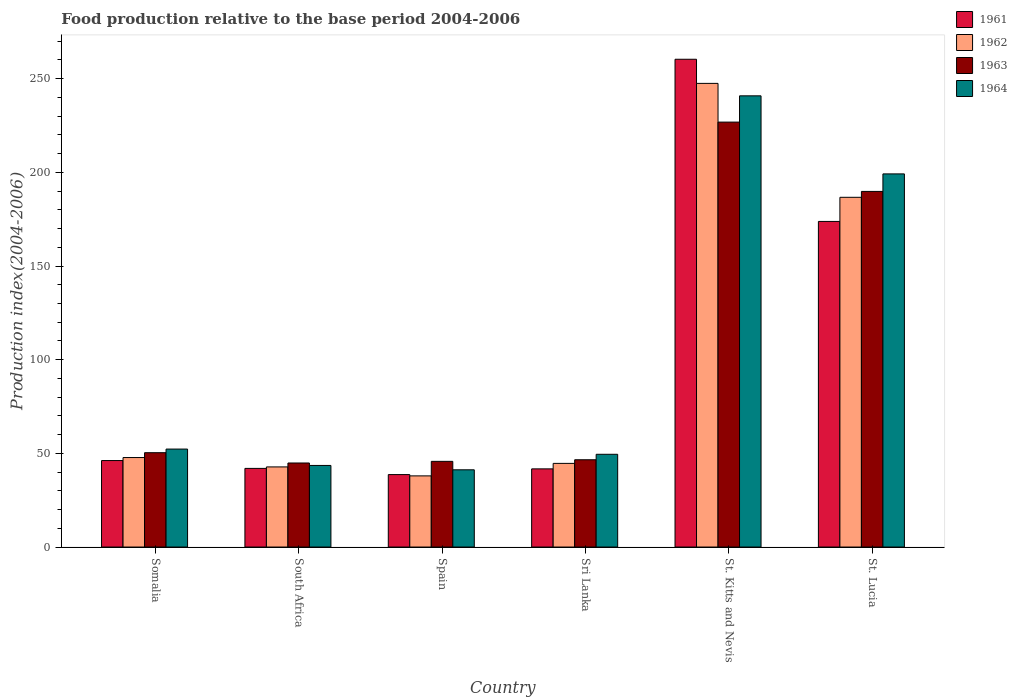How many different coloured bars are there?
Provide a succinct answer. 4. How many groups of bars are there?
Ensure brevity in your answer.  6. Are the number of bars on each tick of the X-axis equal?
Offer a terse response. Yes. How many bars are there on the 5th tick from the left?
Give a very brief answer. 4. How many bars are there on the 1st tick from the right?
Offer a terse response. 4. What is the label of the 6th group of bars from the left?
Provide a short and direct response. St. Lucia. In how many cases, is the number of bars for a given country not equal to the number of legend labels?
Your answer should be compact. 0. What is the food production index in 1964 in Somalia?
Your response must be concise. 52.3. Across all countries, what is the maximum food production index in 1962?
Make the answer very short. 247.5. Across all countries, what is the minimum food production index in 1963?
Your response must be concise. 44.87. In which country was the food production index in 1963 maximum?
Give a very brief answer. St. Kitts and Nevis. What is the total food production index in 1964 in the graph?
Make the answer very short. 626.63. What is the difference between the food production index in 1962 in Spain and that in Sri Lanka?
Offer a very short reply. -6.67. What is the difference between the food production index in 1964 in South Africa and the food production index in 1963 in St. Kitts and Nevis?
Provide a short and direct response. -183.27. What is the average food production index in 1963 per country?
Make the answer very short. 100.7. What is the difference between the food production index of/in 1961 and food production index of/in 1964 in Somalia?
Your answer should be very brief. -6.13. In how many countries, is the food production index in 1962 greater than 260?
Provide a succinct answer. 0. What is the ratio of the food production index in 1961 in St. Kitts and Nevis to that in St. Lucia?
Your answer should be very brief. 1.5. Is the food production index in 1961 in Sri Lanka less than that in St. Lucia?
Offer a very short reply. Yes. What is the difference between the highest and the second highest food production index in 1963?
Your answer should be very brief. 176.47. What is the difference between the highest and the lowest food production index in 1961?
Your response must be concise. 221.69. In how many countries, is the food production index in 1964 greater than the average food production index in 1964 taken over all countries?
Offer a very short reply. 2. Is it the case that in every country, the sum of the food production index in 1964 and food production index in 1962 is greater than the sum of food production index in 1961 and food production index in 1963?
Offer a terse response. No. What does the 1st bar from the left in South Africa represents?
Provide a short and direct response. 1961. What does the 1st bar from the right in Somalia represents?
Provide a succinct answer. 1964. Is it the case that in every country, the sum of the food production index in 1963 and food production index in 1961 is greater than the food production index in 1964?
Keep it short and to the point. Yes. How many countries are there in the graph?
Ensure brevity in your answer.  6. Does the graph contain any zero values?
Keep it short and to the point. No. Does the graph contain grids?
Provide a succinct answer. No. How are the legend labels stacked?
Offer a very short reply. Vertical. What is the title of the graph?
Give a very brief answer. Food production relative to the base period 2004-2006. Does "1999" appear as one of the legend labels in the graph?
Offer a very short reply. No. What is the label or title of the Y-axis?
Your answer should be compact. Production index(2004-2006). What is the Production index(2004-2006) of 1961 in Somalia?
Your answer should be very brief. 46.17. What is the Production index(2004-2006) of 1962 in Somalia?
Your answer should be very brief. 47.78. What is the Production index(2004-2006) in 1963 in Somalia?
Give a very brief answer. 50.36. What is the Production index(2004-2006) of 1964 in Somalia?
Ensure brevity in your answer.  52.3. What is the Production index(2004-2006) in 1961 in South Africa?
Your answer should be compact. 41.98. What is the Production index(2004-2006) in 1962 in South Africa?
Your answer should be compact. 42.77. What is the Production index(2004-2006) in 1963 in South Africa?
Offer a very short reply. 44.87. What is the Production index(2004-2006) in 1964 in South Africa?
Make the answer very short. 43.56. What is the Production index(2004-2006) in 1961 in Spain?
Offer a very short reply. 38.68. What is the Production index(2004-2006) in 1962 in Spain?
Your response must be concise. 37.99. What is the Production index(2004-2006) in 1963 in Spain?
Ensure brevity in your answer.  45.74. What is the Production index(2004-2006) in 1964 in Spain?
Offer a very short reply. 41.23. What is the Production index(2004-2006) in 1961 in Sri Lanka?
Make the answer very short. 41.73. What is the Production index(2004-2006) of 1962 in Sri Lanka?
Your answer should be compact. 44.66. What is the Production index(2004-2006) of 1963 in Sri Lanka?
Your answer should be very brief. 46.59. What is the Production index(2004-2006) of 1964 in Sri Lanka?
Keep it short and to the point. 49.51. What is the Production index(2004-2006) of 1961 in St. Kitts and Nevis?
Provide a short and direct response. 260.37. What is the Production index(2004-2006) in 1962 in St. Kitts and Nevis?
Your response must be concise. 247.5. What is the Production index(2004-2006) of 1963 in St. Kitts and Nevis?
Make the answer very short. 226.83. What is the Production index(2004-2006) in 1964 in St. Kitts and Nevis?
Your response must be concise. 240.85. What is the Production index(2004-2006) of 1961 in St. Lucia?
Offer a terse response. 173.81. What is the Production index(2004-2006) in 1962 in St. Lucia?
Offer a very short reply. 186.69. What is the Production index(2004-2006) of 1963 in St. Lucia?
Keep it short and to the point. 189.83. What is the Production index(2004-2006) of 1964 in St. Lucia?
Provide a short and direct response. 199.18. Across all countries, what is the maximum Production index(2004-2006) of 1961?
Provide a short and direct response. 260.37. Across all countries, what is the maximum Production index(2004-2006) in 1962?
Your response must be concise. 247.5. Across all countries, what is the maximum Production index(2004-2006) of 1963?
Your answer should be compact. 226.83. Across all countries, what is the maximum Production index(2004-2006) of 1964?
Keep it short and to the point. 240.85. Across all countries, what is the minimum Production index(2004-2006) in 1961?
Offer a very short reply. 38.68. Across all countries, what is the minimum Production index(2004-2006) in 1962?
Keep it short and to the point. 37.99. Across all countries, what is the minimum Production index(2004-2006) in 1963?
Offer a very short reply. 44.87. Across all countries, what is the minimum Production index(2004-2006) of 1964?
Ensure brevity in your answer.  41.23. What is the total Production index(2004-2006) in 1961 in the graph?
Your answer should be very brief. 602.74. What is the total Production index(2004-2006) in 1962 in the graph?
Give a very brief answer. 607.39. What is the total Production index(2004-2006) of 1963 in the graph?
Your answer should be compact. 604.22. What is the total Production index(2004-2006) of 1964 in the graph?
Ensure brevity in your answer.  626.63. What is the difference between the Production index(2004-2006) in 1961 in Somalia and that in South Africa?
Your answer should be very brief. 4.19. What is the difference between the Production index(2004-2006) in 1962 in Somalia and that in South Africa?
Offer a very short reply. 5.01. What is the difference between the Production index(2004-2006) in 1963 in Somalia and that in South Africa?
Your response must be concise. 5.49. What is the difference between the Production index(2004-2006) of 1964 in Somalia and that in South Africa?
Provide a short and direct response. 8.74. What is the difference between the Production index(2004-2006) in 1961 in Somalia and that in Spain?
Your answer should be very brief. 7.49. What is the difference between the Production index(2004-2006) in 1962 in Somalia and that in Spain?
Ensure brevity in your answer.  9.79. What is the difference between the Production index(2004-2006) in 1963 in Somalia and that in Spain?
Ensure brevity in your answer.  4.62. What is the difference between the Production index(2004-2006) of 1964 in Somalia and that in Spain?
Make the answer very short. 11.07. What is the difference between the Production index(2004-2006) in 1961 in Somalia and that in Sri Lanka?
Offer a terse response. 4.44. What is the difference between the Production index(2004-2006) of 1962 in Somalia and that in Sri Lanka?
Provide a short and direct response. 3.12. What is the difference between the Production index(2004-2006) of 1963 in Somalia and that in Sri Lanka?
Your answer should be compact. 3.77. What is the difference between the Production index(2004-2006) of 1964 in Somalia and that in Sri Lanka?
Provide a short and direct response. 2.79. What is the difference between the Production index(2004-2006) in 1961 in Somalia and that in St. Kitts and Nevis?
Your answer should be compact. -214.2. What is the difference between the Production index(2004-2006) of 1962 in Somalia and that in St. Kitts and Nevis?
Provide a short and direct response. -199.72. What is the difference between the Production index(2004-2006) of 1963 in Somalia and that in St. Kitts and Nevis?
Offer a terse response. -176.47. What is the difference between the Production index(2004-2006) of 1964 in Somalia and that in St. Kitts and Nevis?
Offer a terse response. -188.55. What is the difference between the Production index(2004-2006) in 1961 in Somalia and that in St. Lucia?
Keep it short and to the point. -127.64. What is the difference between the Production index(2004-2006) of 1962 in Somalia and that in St. Lucia?
Make the answer very short. -138.91. What is the difference between the Production index(2004-2006) in 1963 in Somalia and that in St. Lucia?
Offer a very short reply. -139.47. What is the difference between the Production index(2004-2006) of 1964 in Somalia and that in St. Lucia?
Give a very brief answer. -146.88. What is the difference between the Production index(2004-2006) of 1961 in South Africa and that in Spain?
Ensure brevity in your answer.  3.3. What is the difference between the Production index(2004-2006) of 1962 in South Africa and that in Spain?
Provide a short and direct response. 4.78. What is the difference between the Production index(2004-2006) of 1963 in South Africa and that in Spain?
Your answer should be compact. -0.87. What is the difference between the Production index(2004-2006) in 1964 in South Africa and that in Spain?
Keep it short and to the point. 2.33. What is the difference between the Production index(2004-2006) in 1962 in South Africa and that in Sri Lanka?
Your answer should be very brief. -1.89. What is the difference between the Production index(2004-2006) in 1963 in South Africa and that in Sri Lanka?
Provide a succinct answer. -1.72. What is the difference between the Production index(2004-2006) in 1964 in South Africa and that in Sri Lanka?
Provide a short and direct response. -5.95. What is the difference between the Production index(2004-2006) in 1961 in South Africa and that in St. Kitts and Nevis?
Provide a short and direct response. -218.39. What is the difference between the Production index(2004-2006) of 1962 in South Africa and that in St. Kitts and Nevis?
Offer a terse response. -204.73. What is the difference between the Production index(2004-2006) in 1963 in South Africa and that in St. Kitts and Nevis?
Your answer should be very brief. -181.96. What is the difference between the Production index(2004-2006) of 1964 in South Africa and that in St. Kitts and Nevis?
Your answer should be compact. -197.29. What is the difference between the Production index(2004-2006) in 1961 in South Africa and that in St. Lucia?
Give a very brief answer. -131.83. What is the difference between the Production index(2004-2006) of 1962 in South Africa and that in St. Lucia?
Offer a terse response. -143.92. What is the difference between the Production index(2004-2006) of 1963 in South Africa and that in St. Lucia?
Your answer should be very brief. -144.96. What is the difference between the Production index(2004-2006) in 1964 in South Africa and that in St. Lucia?
Provide a succinct answer. -155.62. What is the difference between the Production index(2004-2006) in 1961 in Spain and that in Sri Lanka?
Offer a terse response. -3.05. What is the difference between the Production index(2004-2006) of 1962 in Spain and that in Sri Lanka?
Provide a succinct answer. -6.67. What is the difference between the Production index(2004-2006) of 1963 in Spain and that in Sri Lanka?
Provide a succinct answer. -0.85. What is the difference between the Production index(2004-2006) of 1964 in Spain and that in Sri Lanka?
Keep it short and to the point. -8.28. What is the difference between the Production index(2004-2006) of 1961 in Spain and that in St. Kitts and Nevis?
Provide a succinct answer. -221.69. What is the difference between the Production index(2004-2006) of 1962 in Spain and that in St. Kitts and Nevis?
Make the answer very short. -209.51. What is the difference between the Production index(2004-2006) of 1963 in Spain and that in St. Kitts and Nevis?
Your response must be concise. -181.09. What is the difference between the Production index(2004-2006) in 1964 in Spain and that in St. Kitts and Nevis?
Your answer should be very brief. -199.62. What is the difference between the Production index(2004-2006) of 1961 in Spain and that in St. Lucia?
Give a very brief answer. -135.13. What is the difference between the Production index(2004-2006) in 1962 in Spain and that in St. Lucia?
Keep it short and to the point. -148.7. What is the difference between the Production index(2004-2006) of 1963 in Spain and that in St. Lucia?
Provide a short and direct response. -144.09. What is the difference between the Production index(2004-2006) of 1964 in Spain and that in St. Lucia?
Keep it short and to the point. -157.95. What is the difference between the Production index(2004-2006) in 1961 in Sri Lanka and that in St. Kitts and Nevis?
Make the answer very short. -218.64. What is the difference between the Production index(2004-2006) in 1962 in Sri Lanka and that in St. Kitts and Nevis?
Give a very brief answer. -202.84. What is the difference between the Production index(2004-2006) of 1963 in Sri Lanka and that in St. Kitts and Nevis?
Keep it short and to the point. -180.24. What is the difference between the Production index(2004-2006) in 1964 in Sri Lanka and that in St. Kitts and Nevis?
Your response must be concise. -191.34. What is the difference between the Production index(2004-2006) of 1961 in Sri Lanka and that in St. Lucia?
Give a very brief answer. -132.08. What is the difference between the Production index(2004-2006) in 1962 in Sri Lanka and that in St. Lucia?
Provide a succinct answer. -142.03. What is the difference between the Production index(2004-2006) in 1963 in Sri Lanka and that in St. Lucia?
Your answer should be compact. -143.24. What is the difference between the Production index(2004-2006) in 1964 in Sri Lanka and that in St. Lucia?
Provide a short and direct response. -149.67. What is the difference between the Production index(2004-2006) in 1961 in St. Kitts and Nevis and that in St. Lucia?
Your answer should be very brief. 86.56. What is the difference between the Production index(2004-2006) in 1962 in St. Kitts and Nevis and that in St. Lucia?
Keep it short and to the point. 60.81. What is the difference between the Production index(2004-2006) in 1964 in St. Kitts and Nevis and that in St. Lucia?
Give a very brief answer. 41.67. What is the difference between the Production index(2004-2006) of 1961 in Somalia and the Production index(2004-2006) of 1963 in South Africa?
Offer a very short reply. 1.3. What is the difference between the Production index(2004-2006) in 1961 in Somalia and the Production index(2004-2006) in 1964 in South Africa?
Give a very brief answer. 2.61. What is the difference between the Production index(2004-2006) in 1962 in Somalia and the Production index(2004-2006) in 1963 in South Africa?
Make the answer very short. 2.91. What is the difference between the Production index(2004-2006) of 1962 in Somalia and the Production index(2004-2006) of 1964 in South Africa?
Offer a very short reply. 4.22. What is the difference between the Production index(2004-2006) of 1961 in Somalia and the Production index(2004-2006) of 1962 in Spain?
Provide a succinct answer. 8.18. What is the difference between the Production index(2004-2006) of 1961 in Somalia and the Production index(2004-2006) of 1963 in Spain?
Provide a short and direct response. 0.43. What is the difference between the Production index(2004-2006) in 1961 in Somalia and the Production index(2004-2006) in 1964 in Spain?
Provide a short and direct response. 4.94. What is the difference between the Production index(2004-2006) of 1962 in Somalia and the Production index(2004-2006) of 1963 in Spain?
Your response must be concise. 2.04. What is the difference between the Production index(2004-2006) in 1962 in Somalia and the Production index(2004-2006) in 1964 in Spain?
Your response must be concise. 6.55. What is the difference between the Production index(2004-2006) of 1963 in Somalia and the Production index(2004-2006) of 1964 in Spain?
Make the answer very short. 9.13. What is the difference between the Production index(2004-2006) of 1961 in Somalia and the Production index(2004-2006) of 1962 in Sri Lanka?
Give a very brief answer. 1.51. What is the difference between the Production index(2004-2006) in 1961 in Somalia and the Production index(2004-2006) in 1963 in Sri Lanka?
Give a very brief answer. -0.42. What is the difference between the Production index(2004-2006) in 1961 in Somalia and the Production index(2004-2006) in 1964 in Sri Lanka?
Provide a succinct answer. -3.34. What is the difference between the Production index(2004-2006) of 1962 in Somalia and the Production index(2004-2006) of 1963 in Sri Lanka?
Your answer should be compact. 1.19. What is the difference between the Production index(2004-2006) in 1962 in Somalia and the Production index(2004-2006) in 1964 in Sri Lanka?
Keep it short and to the point. -1.73. What is the difference between the Production index(2004-2006) in 1961 in Somalia and the Production index(2004-2006) in 1962 in St. Kitts and Nevis?
Your response must be concise. -201.33. What is the difference between the Production index(2004-2006) of 1961 in Somalia and the Production index(2004-2006) of 1963 in St. Kitts and Nevis?
Your answer should be very brief. -180.66. What is the difference between the Production index(2004-2006) in 1961 in Somalia and the Production index(2004-2006) in 1964 in St. Kitts and Nevis?
Offer a very short reply. -194.68. What is the difference between the Production index(2004-2006) in 1962 in Somalia and the Production index(2004-2006) in 1963 in St. Kitts and Nevis?
Give a very brief answer. -179.05. What is the difference between the Production index(2004-2006) in 1962 in Somalia and the Production index(2004-2006) in 1964 in St. Kitts and Nevis?
Keep it short and to the point. -193.07. What is the difference between the Production index(2004-2006) in 1963 in Somalia and the Production index(2004-2006) in 1964 in St. Kitts and Nevis?
Give a very brief answer. -190.49. What is the difference between the Production index(2004-2006) in 1961 in Somalia and the Production index(2004-2006) in 1962 in St. Lucia?
Offer a terse response. -140.52. What is the difference between the Production index(2004-2006) in 1961 in Somalia and the Production index(2004-2006) in 1963 in St. Lucia?
Offer a terse response. -143.66. What is the difference between the Production index(2004-2006) in 1961 in Somalia and the Production index(2004-2006) in 1964 in St. Lucia?
Make the answer very short. -153.01. What is the difference between the Production index(2004-2006) in 1962 in Somalia and the Production index(2004-2006) in 1963 in St. Lucia?
Offer a very short reply. -142.05. What is the difference between the Production index(2004-2006) of 1962 in Somalia and the Production index(2004-2006) of 1964 in St. Lucia?
Your answer should be compact. -151.4. What is the difference between the Production index(2004-2006) of 1963 in Somalia and the Production index(2004-2006) of 1964 in St. Lucia?
Keep it short and to the point. -148.82. What is the difference between the Production index(2004-2006) in 1961 in South Africa and the Production index(2004-2006) in 1962 in Spain?
Give a very brief answer. 3.99. What is the difference between the Production index(2004-2006) in 1961 in South Africa and the Production index(2004-2006) in 1963 in Spain?
Provide a short and direct response. -3.76. What is the difference between the Production index(2004-2006) of 1962 in South Africa and the Production index(2004-2006) of 1963 in Spain?
Ensure brevity in your answer.  -2.97. What is the difference between the Production index(2004-2006) in 1962 in South Africa and the Production index(2004-2006) in 1964 in Spain?
Provide a short and direct response. 1.54. What is the difference between the Production index(2004-2006) in 1963 in South Africa and the Production index(2004-2006) in 1964 in Spain?
Make the answer very short. 3.64. What is the difference between the Production index(2004-2006) in 1961 in South Africa and the Production index(2004-2006) in 1962 in Sri Lanka?
Your answer should be very brief. -2.68. What is the difference between the Production index(2004-2006) of 1961 in South Africa and the Production index(2004-2006) of 1963 in Sri Lanka?
Your answer should be compact. -4.61. What is the difference between the Production index(2004-2006) of 1961 in South Africa and the Production index(2004-2006) of 1964 in Sri Lanka?
Offer a terse response. -7.53. What is the difference between the Production index(2004-2006) of 1962 in South Africa and the Production index(2004-2006) of 1963 in Sri Lanka?
Make the answer very short. -3.82. What is the difference between the Production index(2004-2006) of 1962 in South Africa and the Production index(2004-2006) of 1964 in Sri Lanka?
Keep it short and to the point. -6.74. What is the difference between the Production index(2004-2006) in 1963 in South Africa and the Production index(2004-2006) in 1964 in Sri Lanka?
Give a very brief answer. -4.64. What is the difference between the Production index(2004-2006) in 1961 in South Africa and the Production index(2004-2006) in 1962 in St. Kitts and Nevis?
Give a very brief answer. -205.52. What is the difference between the Production index(2004-2006) in 1961 in South Africa and the Production index(2004-2006) in 1963 in St. Kitts and Nevis?
Keep it short and to the point. -184.85. What is the difference between the Production index(2004-2006) in 1961 in South Africa and the Production index(2004-2006) in 1964 in St. Kitts and Nevis?
Your answer should be compact. -198.87. What is the difference between the Production index(2004-2006) in 1962 in South Africa and the Production index(2004-2006) in 1963 in St. Kitts and Nevis?
Offer a terse response. -184.06. What is the difference between the Production index(2004-2006) in 1962 in South Africa and the Production index(2004-2006) in 1964 in St. Kitts and Nevis?
Ensure brevity in your answer.  -198.08. What is the difference between the Production index(2004-2006) of 1963 in South Africa and the Production index(2004-2006) of 1964 in St. Kitts and Nevis?
Offer a very short reply. -195.98. What is the difference between the Production index(2004-2006) of 1961 in South Africa and the Production index(2004-2006) of 1962 in St. Lucia?
Give a very brief answer. -144.71. What is the difference between the Production index(2004-2006) in 1961 in South Africa and the Production index(2004-2006) in 1963 in St. Lucia?
Give a very brief answer. -147.85. What is the difference between the Production index(2004-2006) of 1961 in South Africa and the Production index(2004-2006) of 1964 in St. Lucia?
Ensure brevity in your answer.  -157.2. What is the difference between the Production index(2004-2006) in 1962 in South Africa and the Production index(2004-2006) in 1963 in St. Lucia?
Keep it short and to the point. -147.06. What is the difference between the Production index(2004-2006) of 1962 in South Africa and the Production index(2004-2006) of 1964 in St. Lucia?
Offer a terse response. -156.41. What is the difference between the Production index(2004-2006) in 1963 in South Africa and the Production index(2004-2006) in 1964 in St. Lucia?
Provide a short and direct response. -154.31. What is the difference between the Production index(2004-2006) in 1961 in Spain and the Production index(2004-2006) in 1962 in Sri Lanka?
Provide a short and direct response. -5.98. What is the difference between the Production index(2004-2006) in 1961 in Spain and the Production index(2004-2006) in 1963 in Sri Lanka?
Ensure brevity in your answer.  -7.91. What is the difference between the Production index(2004-2006) of 1961 in Spain and the Production index(2004-2006) of 1964 in Sri Lanka?
Provide a succinct answer. -10.83. What is the difference between the Production index(2004-2006) of 1962 in Spain and the Production index(2004-2006) of 1964 in Sri Lanka?
Make the answer very short. -11.52. What is the difference between the Production index(2004-2006) in 1963 in Spain and the Production index(2004-2006) in 1964 in Sri Lanka?
Make the answer very short. -3.77. What is the difference between the Production index(2004-2006) in 1961 in Spain and the Production index(2004-2006) in 1962 in St. Kitts and Nevis?
Your answer should be very brief. -208.82. What is the difference between the Production index(2004-2006) of 1961 in Spain and the Production index(2004-2006) of 1963 in St. Kitts and Nevis?
Your answer should be very brief. -188.15. What is the difference between the Production index(2004-2006) in 1961 in Spain and the Production index(2004-2006) in 1964 in St. Kitts and Nevis?
Your answer should be compact. -202.17. What is the difference between the Production index(2004-2006) in 1962 in Spain and the Production index(2004-2006) in 1963 in St. Kitts and Nevis?
Ensure brevity in your answer.  -188.84. What is the difference between the Production index(2004-2006) of 1962 in Spain and the Production index(2004-2006) of 1964 in St. Kitts and Nevis?
Give a very brief answer. -202.86. What is the difference between the Production index(2004-2006) of 1963 in Spain and the Production index(2004-2006) of 1964 in St. Kitts and Nevis?
Provide a short and direct response. -195.11. What is the difference between the Production index(2004-2006) in 1961 in Spain and the Production index(2004-2006) in 1962 in St. Lucia?
Provide a short and direct response. -148.01. What is the difference between the Production index(2004-2006) in 1961 in Spain and the Production index(2004-2006) in 1963 in St. Lucia?
Provide a short and direct response. -151.15. What is the difference between the Production index(2004-2006) of 1961 in Spain and the Production index(2004-2006) of 1964 in St. Lucia?
Give a very brief answer. -160.5. What is the difference between the Production index(2004-2006) in 1962 in Spain and the Production index(2004-2006) in 1963 in St. Lucia?
Your answer should be compact. -151.84. What is the difference between the Production index(2004-2006) in 1962 in Spain and the Production index(2004-2006) in 1964 in St. Lucia?
Your response must be concise. -161.19. What is the difference between the Production index(2004-2006) in 1963 in Spain and the Production index(2004-2006) in 1964 in St. Lucia?
Provide a succinct answer. -153.44. What is the difference between the Production index(2004-2006) in 1961 in Sri Lanka and the Production index(2004-2006) in 1962 in St. Kitts and Nevis?
Provide a succinct answer. -205.77. What is the difference between the Production index(2004-2006) in 1961 in Sri Lanka and the Production index(2004-2006) in 1963 in St. Kitts and Nevis?
Provide a succinct answer. -185.1. What is the difference between the Production index(2004-2006) of 1961 in Sri Lanka and the Production index(2004-2006) of 1964 in St. Kitts and Nevis?
Give a very brief answer. -199.12. What is the difference between the Production index(2004-2006) in 1962 in Sri Lanka and the Production index(2004-2006) in 1963 in St. Kitts and Nevis?
Make the answer very short. -182.17. What is the difference between the Production index(2004-2006) in 1962 in Sri Lanka and the Production index(2004-2006) in 1964 in St. Kitts and Nevis?
Your response must be concise. -196.19. What is the difference between the Production index(2004-2006) in 1963 in Sri Lanka and the Production index(2004-2006) in 1964 in St. Kitts and Nevis?
Make the answer very short. -194.26. What is the difference between the Production index(2004-2006) in 1961 in Sri Lanka and the Production index(2004-2006) in 1962 in St. Lucia?
Provide a short and direct response. -144.96. What is the difference between the Production index(2004-2006) in 1961 in Sri Lanka and the Production index(2004-2006) in 1963 in St. Lucia?
Provide a succinct answer. -148.1. What is the difference between the Production index(2004-2006) in 1961 in Sri Lanka and the Production index(2004-2006) in 1964 in St. Lucia?
Offer a very short reply. -157.45. What is the difference between the Production index(2004-2006) of 1962 in Sri Lanka and the Production index(2004-2006) of 1963 in St. Lucia?
Your answer should be very brief. -145.17. What is the difference between the Production index(2004-2006) of 1962 in Sri Lanka and the Production index(2004-2006) of 1964 in St. Lucia?
Provide a short and direct response. -154.52. What is the difference between the Production index(2004-2006) of 1963 in Sri Lanka and the Production index(2004-2006) of 1964 in St. Lucia?
Offer a very short reply. -152.59. What is the difference between the Production index(2004-2006) in 1961 in St. Kitts and Nevis and the Production index(2004-2006) in 1962 in St. Lucia?
Offer a terse response. 73.68. What is the difference between the Production index(2004-2006) of 1961 in St. Kitts and Nevis and the Production index(2004-2006) of 1963 in St. Lucia?
Offer a very short reply. 70.54. What is the difference between the Production index(2004-2006) of 1961 in St. Kitts and Nevis and the Production index(2004-2006) of 1964 in St. Lucia?
Offer a terse response. 61.19. What is the difference between the Production index(2004-2006) in 1962 in St. Kitts and Nevis and the Production index(2004-2006) in 1963 in St. Lucia?
Your answer should be compact. 57.67. What is the difference between the Production index(2004-2006) in 1962 in St. Kitts and Nevis and the Production index(2004-2006) in 1964 in St. Lucia?
Offer a very short reply. 48.32. What is the difference between the Production index(2004-2006) of 1963 in St. Kitts and Nevis and the Production index(2004-2006) of 1964 in St. Lucia?
Keep it short and to the point. 27.65. What is the average Production index(2004-2006) in 1961 per country?
Your answer should be very brief. 100.46. What is the average Production index(2004-2006) of 1962 per country?
Give a very brief answer. 101.23. What is the average Production index(2004-2006) of 1963 per country?
Provide a succinct answer. 100.7. What is the average Production index(2004-2006) in 1964 per country?
Make the answer very short. 104.44. What is the difference between the Production index(2004-2006) of 1961 and Production index(2004-2006) of 1962 in Somalia?
Ensure brevity in your answer.  -1.61. What is the difference between the Production index(2004-2006) of 1961 and Production index(2004-2006) of 1963 in Somalia?
Your answer should be very brief. -4.19. What is the difference between the Production index(2004-2006) in 1961 and Production index(2004-2006) in 1964 in Somalia?
Offer a terse response. -6.13. What is the difference between the Production index(2004-2006) in 1962 and Production index(2004-2006) in 1963 in Somalia?
Give a very brief answer. -2.58. What is the difference between the Production index(2004-2006) in 1962 and Production index(2004-2006) in 1964 in Somalia?
Provide a succinct answer. -4.52. What is the difference between the Production index(2004-2006) in 1963 and Production index(2004-2006) in 1964 in Somalia?
Give a very brief answer. -1.94. What is the difference between the Production index(2004-2006) in 1961 and Production index(2004-2006) in 1962 in South Africa?
Your answer should be compact. -0.79. What is the difference between the Production index(2004-2006) of 1961 and Production index(2004-2006) of 1963 in South Africa?
Provide a succinct answer. -2.89. What is the difference between the Production index(2004-2006) of 1961 and Production index(2004-2006) of 1964 in South Africa?
Offer a very short reply. -1.58. What is the difference between the Production index(2004-2006) of 1962 and Production index(2004-2006) of 1963 in South Africa?
Your answer should be compact. -2.1. What is the difference between the Production index(2004-2006) in 1962 and Production index(2004-2006) in 1964 in South Africa?
Offer a very short reply. -0.79. What is the difference between the Production index(2004-2006) of 1963 and Production index(2004-2006) of 1964 in South Africa?
Provide a short and direct response. 1.31. What is the difference between the Production index(2004-2006) in 1961 and Production index(2004-2006) in 1962 in Spain?
Your response must be concise. 0.69. What is the difference between the Production index(2004-2006) in 1961 and Production index(2004-2006) in 1963 in Spain?
Provide a succinct answer. -7.06. What is the difference between the Production index(2004-2006) of 1961 and Production index(2004-2006) of 1964 in Spain?
Make the answer very short. -2.55. What is the difference between the Production index(2004-2006) in 1962 and Production index(2004-2006) in 1963 in Spain?
Ensure brevity in your answer.  -7.75. What is the difference between the Production index(2004-2006) in 1962 and Production index(2004-2006) in 1964 in Spain?
Give a very brief answer. -3.24. What is the difference between the Production index(2004-2006) of 1963 and Production index(2004-2006) of 1964 in Spain?
Ensure brevity in your answer.  4.51. What is the difference between the Production index(2004-2006) in 1961 and Production index(2004-2006) in 1962 in Sri Lanka?
Your answer should be compact. -2.93. What is the difference between the Production index(2004-2006) of 1961 and Production index(2004-2006) of 1963 in Sri Lanka?
Your response must be concise. -4.86. What is the difference between the Production index(2004-2006) in 1961 and Production index(2004-2006) in 1964 in Sri Lanka?
Keep it short and to the point. -7.78. What is the difference between the Production index(2004-2006) of 1962 and Production index(2004-2006) of 1963 in Sri Lanka?
Make the answer very short. -1.93. What is the difference between the Production index(2004-2006) in 1962 and Production index(2004-2006) in 1964 in Sri Lanka?
Give a very brief answer. -4.85. What is the difference between the Production index(2004-2006) in 1963 and Production index(2004-2006) in 1964 in Sri Lanka?
Ensure brevity in your answer.  -2.92. What is the difference between the Production index(2004-2006) of 1961 and Production index(2004-2006) of 1962 in St. Kitts and Nevis?
Offer a very short reply. 12.87. What is the difference between the Production index(2004-2006) in 1961 and Production index(2004-2006) in 1963 in St. Kitts and Nevis?
Provide a succinct answer. 33.54. What is the difference between the Production index(2004-2006) of 1961 and Production index(2004-2006) of 1964 in St. Kitts and Nevis?
Provide a short and direct response. 19.52. What is the difference between the Production index(2004-2006) of 1962 and Production index(2004-2006) of 1963 in St. Kitts and Nevis?
Make the answer very short. 20.67. What is the difference between the Production index(2004-2006) in 1962 and Production index(2004-2006) in 1964 in St. Kitts and Nevis?
Ensure brevity in your answer.  6.65. What is the difference between the Production index(2004-2006) in 1963 and Production index(2004-2006) in 1964 in St. Kitts and Nevis?
Your answer should be compact. -14.02. What is the difference between the Production index(2004-2006) of 1961 and Production index(2004-2006) of 1962 in St. Lucia?
Your answer should be compact. -12.88. What is the difference between the Production index(2004-2006) of 1961 and Production index(2004-2006) of 1963 in St. Lucia?
Your answer should be compact. -16.02. What is the difference between the Production index(2004-2006) in 1961 and Production index(2004-2006) in 1964 in St. Lucia?
Keep it short and to the point. -25.37. What is the difference between the Production index(2004-2006) in 1962 and Production index(2004-2006) in 1963 in St. Lucia?
Provide a succinct answer. -3.14. What is the difference between the Production index(2004-2006) in 1962 and Production index(2004-2006) in 1964 in St. Lucia?
Give a very brief answer. -12.49. What is the difference between the Production index(2004-2006) in 1963 and Production index(2004-2006) in 1964 in St. Lucia?
Your response must be concise. -9.35. What is the ratio of the Production index(2004-2006) of 1961 in Somalia to that in South Africa?
Keep it short and to the point. 1.1. What is the ratio of the Production index(2004-2006) in 1962 in Somalia to that in South Africa?
Make the answer very short. 1.12. What is the ratio of the Production index(2004-2006) in 1963 in Somalia to that in South Africa?
Keep it short and to the point. 1.12. What is the ratio of the Production index(2004-2006) of 1964 in Somalia to that in South Africa?
Your answer should be very brief. 1.2. What is the ratio of the Production index(2004-2006) of 1961 in Somalia to that in Spain?
Make the answer very short. 1.19. What is the ratio of the Production index(2004-2006) of 1962 in Somalia to that in Spain?
Your answer should be very brief. 1.26. What is the ratio of the Production index(2004-2006) in 1963 in Somalia to that in Spain?
Offer a terse response. 1.1. What is the ratio of the Production index(2004-2006) in 1964 in Somalia to that in Spain?
Ensure brevity in your answer.  1.27. What is the ratio of the Production index(2004-2006) in 1961 in Somalia to that in Sri Lanka?
Provide a short and direct response. 1.11. What is the ratio of the Production index(2004-2006) in 1962 in Somalia to that in Sri Lanka?
Make the answer very short. 1.07. What is the ratio of the Production index(2004-2006) in 1963 in Somalia to that in Sri Lanka?
Give a very brief answer. 1.08. What is the ratio of the Production index(2004-2006) in 1964 in Somalia to that in Sri Lanka?
Make the answer very short. 1.06. What is the ratio of the Production index(2004-2006) in 1961 in Somalia to that in St. Kitts and Nevis?
Keep it short and to the point. 0.18. What is the ratio of the Production index(2004-2006) in 1962 in Somalia to that in St. Kitts and Nevis?
Give a very brief answer. 0.19. What is the ratio of the Production index(2004-2006) of 1963 in Somalia to that in St. Kitts and Nevis?
Make the answer very short. 0.22. What is the ratio of the Production index(2004-2006) of 1964 in Somalia to that in St. Kitts and Nevis?
Your answer should be very brief. 0.22. What is the ratio of the Production index(2004-2006) of 1961 in Somalia to that in St. Lucia?
Make the answer very short. 0.27. What is the ratio of the Production index(2004-2006) in 1962 in Somalia to that in St. Lucia?
Offer a very short reply. 0.26. What is the ratio of the Production index(2004-2006) in 1963 in Somalia to that in St. Lucia?
Your response must be concise. 0.27. What is the ratio of the Production index(2004-2006) of 1964 in Somalia to that in St. Lucia?
Keep it short and to the point. 0.26. What is the ratio of the Production index(2004-2006) in 1961 in South Africa to that in Spain?
Offer a very short reply. 1.09. What is the ratio of the Production index(2004-2006) in 1962 in South Africa to that in Spain?
Provide a succinct answer. 1.13. What is the ratio of the Production index(2004-2006) of 1964 in South Africa to that in Spain?
Your answer should be very brief. 1.06. What is the ratio of the Production index(2004-2006) in 1962 in South Africa to that in Sri Lanka?
Offer a terse response. 0.96. What is the ratio of the Production index(2004-2006) of 1963 in South Africa to that in Sri Lanka?
Provide a short and direct response. 0.96. What is the ratio of the Production index(2004-2006) of 1964 in South Africa to that in Sri Lanka?
Give a very brief answer. 0.88. What is the ratio of the Production index(2004-2006) in 1961 in South Africa to that in St. Kitts and Nevis?
Provide a short and direct response. 0.16. What is the ratio of the Production index(2004-2006) in 1962 in South Africa to that in St. Kitts and Nevis?
Ensure brevity in your answer.  0.17. What is the ratio of the Production index(2004-2006) in 1963 in South Africa to that in St. Kitts and Nevis?
Your answer should be very brief. 0.2. What is the ratio of the Production index(2004-2006) of 1964 in South Africa to that in St. Kitts and Nevis?
Ensure brevity in your answer.  0.18. What is the ratio of the Production index(2004-2006) in 1961 in South Africa to that in St. Lucia?
Ensure brevity in your answer.  0.24. What is the ratio of the Production index(2004-2006) of 1962 in South Africa to that in St. Lucia?
Ensure brevity in your answer.  0.23. What is the ratio of the Production index(2004-2006) in 1963 in South Africa to that in St. Lucia?
Your answer should be compact. 0.24. What is the ratio of the Production index(2004-2006) of 1964 in South Africa to that in St. Lucia?
Your response must be concise. 0.22. What is the ratio of the Production index(2004-2006) of 1961 in Spain to that in Sri Lanka?
Your answer should be very brief. 0.93. What is the ratio of the Production index(2004-2006) of 1962 in Spain to that in Sri Lanka?
Your answer should be very brief. 0.85. What is the ratio of the Production index(2004-2006) of 1963 in Spain to that in Sri Lanka?
Offer a very short reply. 0.98. What is the ratio of the Production index(2004-2006) in 1964 in Spain to that in Sri Lanka?
Ensure brevity in your answer.  0.83. What is the ratio of the Production index(2004-2006) in 1961 in Spain to that in St. Kitts and Nevis?
Make the answer very short. 0.15. What is the ratio of the Production index(2004-2006) of 1962 in Spain to that in St. Kitts and Nevis?
Ensure brevity in your answer.  0.15. What is the ratio of the Production index(2004-2006) in 1963 in Spain to that in St. Kitts and Nevis?
Your answer should be very brief. 0.2. What is the ratio of the Production index(2004-2006) in 1964 in Spain to that in St. Kitts and Nevis?
Your answer should be very brief. 0.17. What is the ratio of the Production index(2004-2006) of 1961 in Spain to that in St. Lucia?
Ensure brevity in your answer.  0.22. What is the ratio of the Production index(2004-2006) in 1962 in Spain to that in St. Lucia?
Give a very brief answer. 0.2. What is the ratio of the Production index(2004-2006) of 1963 in Spain to that in St. Lucia?
Your answer should be very brief. 0.24. What is the ratio of the Production index(2004-2006) of 1964 in Spain to that in St. Lucia?
Provide a short and direct response. 0.21. What is the ratio of the Production index(2004-2006) in 1961 in Sri Lanka to that in St. Kitts and Nevis?
Your answer should be compact. 0.16. What is the ratio of the Production index(2004-2006) of 1962 in Sri Lanka to that in St. Kitts and Nevis?
Ensure brevity in your answer.  0.18. What is the ratio of the Production index(2004-2006) in 1963 in Sri Lanka to that in St. Kitts and Nevis?
Provide a short and direct response. 0.21. What is the ratio of the Production index(2004-2006) in 1964 in Sri Lanka to that in St. Kitts and Nevis?
Ensure brevity in your answer.  0.21. What is the ratio of the Production index(2004-2006) in 1961 in Sri Lanka to that in St. Lucia?
Your response must be concise. 0.24. What is the ratio of the Production index(2004-2006) of 1962 in Sri Lanka to that in St. Lucia?
Keep it short and to the point. 0.24. What is the ratio of the Production index(2004-2006) in 1963 in Sri Lanka to that in St. Lucia?
Your response must be concise. 0.25. What is the ratio of the Production index(2004-2006) in 1964 in Sri Lanka to that in St. Lucia?
Ensure brevity in your answer.  0.25. What is the ratio of the Production index(2004-2006) of 1961 in St. Kitts and Nevis to that in St. Lucia?
Your answer should be very brief. 1.5. What is the ratio of the Production index(2004-2006) in 1962 in St. Kitts and Nevis to that in St. Lucia?
Your response must be concise. 1.33. What is the ratio of the Production index(2004-2006) in 1963 in St. Kitts and Nevis to that in St. Lucia?
Provide a short and direct response. 1.19. What is the ratio of the Production index(2004-2006) in 1964 in St. Kitts and Nevis to that in St. Lucia?
Keep it short and to the point. 1.21. What is the difference between the highest and the second highest Production index(2004-2006) in 1961?
Offer a terse response. 86.56. What is the difference between the highest and the second highest Production index(2004-2006) in 1962?
Offer a very short reply. 60.81. What is the difference between the highest and the second highest Production index(2004-2006) of 1964?
Your response must be concise. 41.67. What is the difference between the highest and the lowest Production index(2004-2006) of 1961?
Provide a succinct answer. 221.69. What is the difference between the highest and the lowest Production index(2004-2006) in 1962?
Offer a terse response. 209.51. What is the difference between the highest and the lowest Production index(2004-2006) of 1963?
Offer a very short reply. 181.96. What is the difference between the highest and the lowest Production index(2004-2006) of 1964?
Your response must be concise. 199.62. 